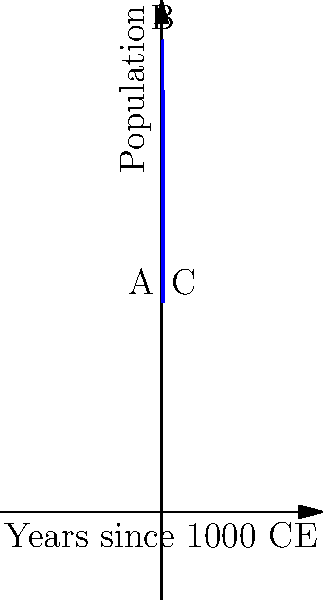The line graph represents the population growth of a medieval European city from 1000 CE to 1050 CE. If point A represents the year 1000 CE, B represents 1025 CE, and C represents 1050 CE, calculate the average rate of change in population between 1025 CE and 1050 CE. How does this compare to the average rate of change between 1000 CE and 1025 CE, and what might this suggest about the city's development and the balance of power during this period? To solve this problem, we'll follow these steps:

1. Determine the population at points A, B, and C:
   A (1000 CE): $f(0) = 5000 + 500(0) - 10(0)^2 = 5000$
   B (1025 CE): $f(25) = 5000 + 500(25) - 10(25)^2 = 5000 + 12500 - 6250 = 11250$
   C (1050 CE): $f(50) = 5000 + 500(50) - 10(50)^2 = 5000 + 25000 - 25000 = 5000$

2. Calculate the average rate of change between B and C (1025-1050 CE):
   $\frac{\text{Change in population}}{\text{Change in time}} = \frac{5000 - 11250}{25} = -250$ people per year

3. Calculate the average rate of change between A and B (1000-1025 CE):
   $\frac{\text{Change in population}}{\text{Change in time}} = \frac{11250 - 5000}{25} = 250$ people per year

4. Compare the rates:
   The rate from 1000-1025 CE is positive (250 people/year), indicating growth.
   The rate from 1025-1050 CE is negative (-250 people/year), indicating decline.

5. Interpretation:
   The shift from growth to decline suggests significant changes in the city's development. This could indicate:
   - Reaching the city's carrying capacity
   - Political instability or power shifts
   - Environmental factors or epidemics
   - Changes in trade routes or economic conditions

   These factors would have impacted the balance of power within the city and potentially in the broader region.
Answer: -250 people/year (1025-1050 CE); opposite of 1000-1025 CE rate, suggesting major sociopolitical or environmental changes affecting power dynamics. 